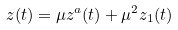Convert formula to latex. <formula><loc_0><loc_0><loc_500><loc_500>z ( t ) = \mu z ^ { a } ( t ) + \mu ^ { 2 } z _ { 1 } ( t )</formula> 